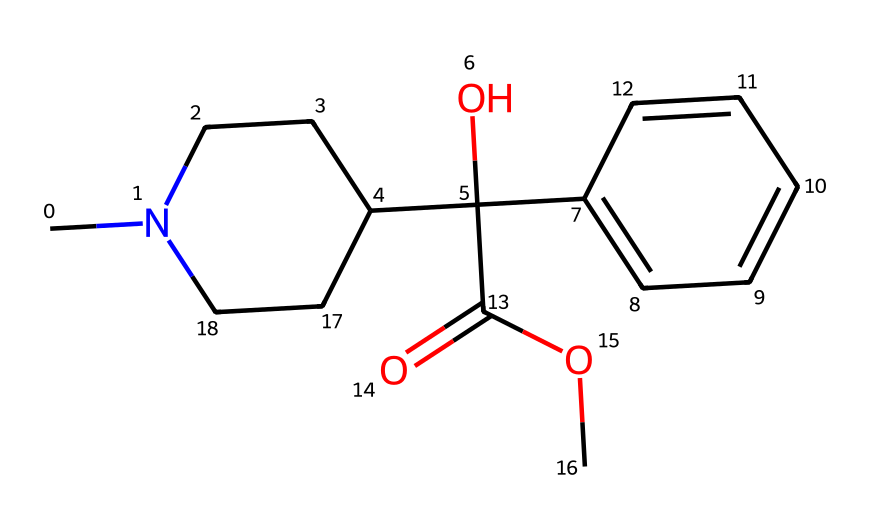What is the main functional group present in atropine? The main functional group in the presented chemical structure is the ester group, identified by the C(=O)O fragment.
Answer: ester How many rings are present in the structure of atropine? The SMILES representation indicates that there is one cyclic structure in the compound, specifically a piperidine ring.
Answer: one How many carbon atoms are there in the structural formula of atropine? By counting the carbon atoms in the SMILES notation (the 'C's and the implied carbons), there are a total of 17 carbon atoms in atropine.
Answer: 17 Is atropine a basic or acidic compound? The presence of a nitrogen atom in a ring structure typically indicates basicity, which is characteristic of alkaloids like atropine.
Answer: basic What type of chemical is atropine classified as? Atropine is classified as an alkaloid due to its nitrogen content and origin from plant sources.
Answer: alkaloid What role does the aromatic ring play in atropine's structure? The aromatic ring (c2ccccc2) contributes to the stability and pharmacological properties of atropine, often enhancing its interactions with biological targets.
Answer: stability What common medical application is associated with atropine? Atropine is commonly used as an antidote for certain types of poisoning, especially those involving nerve agents or organophosphate compounds.
Answer: antidote 